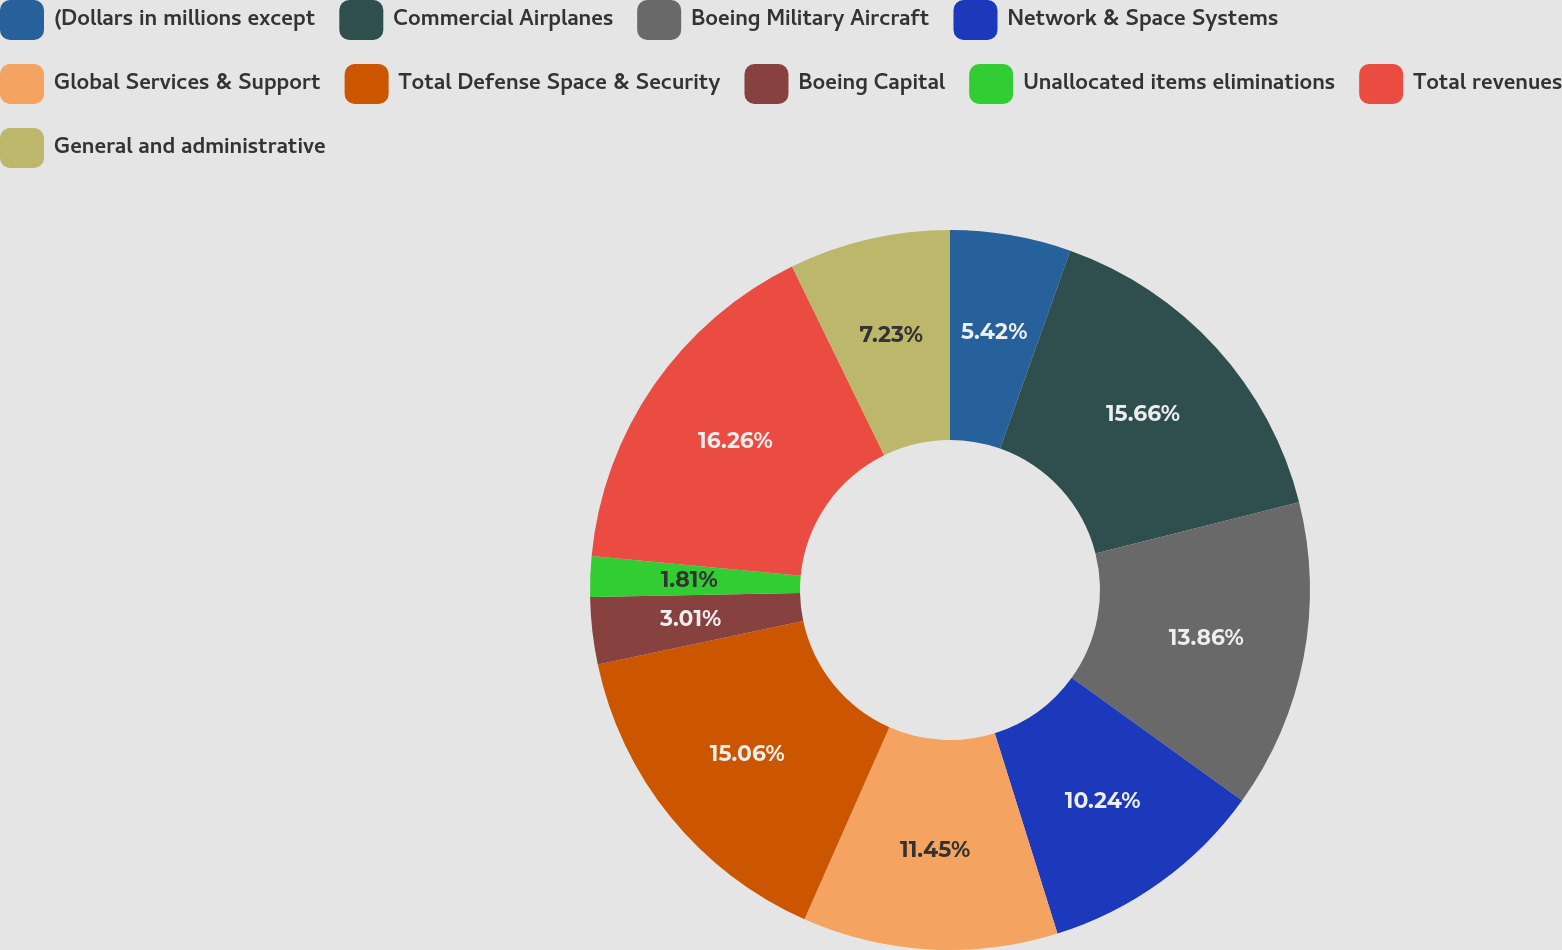<chart> <loc_0><loc_0><loc_500><loc_500><pie_chart><fcel>(Dollars in millions except<fcel>Commercial Airplanes<fcel>Boeing Military Aircraft<fcel>Network & Space Systems<fcel>Global Services & Support<fcel>Total Defense Space & Security<fcel>Boeing Capital<fcel>Unallocated items eliminations<fcel>Total revenues<fcel>General and administrative<nl><fcel>5.42%<fcel>15.66%<fcel>13.86%<fcel>10.24%<fcel>11.45%<fcel>15.06%<fcel>3.01%<fcel>1.81%<fcel>16.27%<fcel>7.23%<nl></chart> 